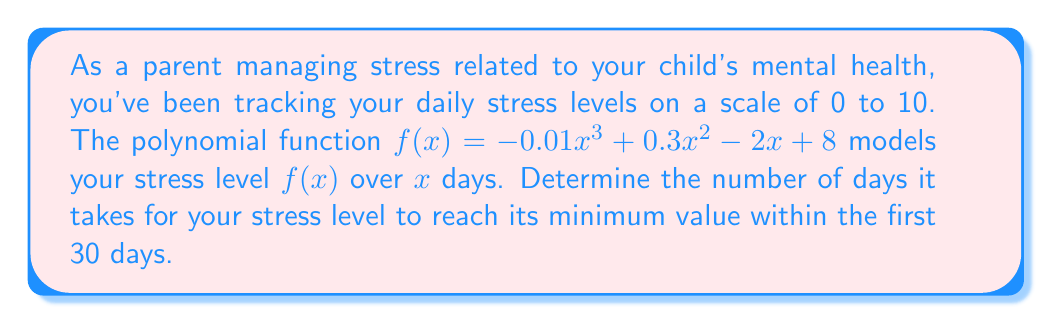Can you solve this math problem? To find the minimum stress level within the first 30 days, we need to follow these steps:

1) First, we need to find the derivative of the function to determine where the slope is zero:
   $f'(x) = -0.03x^2 + 0.6x - 2$

2) Set the derivative equal to zero and solve for x:
   $-0.03x^2 + 0.6x - 2 = 0$

3) This is a quadratic equation. We can solve it using the quadratic formula:
   $x = \frac{-b \pm \sqrt{b^2 - 4ac}}{2a}$

   Where $a = -0.03$, $b = 0.6$, and $c = -2$

4) Plugging in these values:
   $x = \frac{-0.6 \pm \sqrt{0.6^2 - 4(-0.03)(-2)}}{2(-0.03)}$
   $= \frac{-0.6 \pm \sqrt{0.36 - 0.24}}{-0.06}$
   $= \frac{-0.6 \pm \sqrt{0.12}}{-0.06}$
   $= \frac{-0.6 \pm 0.3464}{-0.06}$

5) This gives us two solutions:
   $x_1 = \frac{-0.6 + 0.3464}{-0.06} \approx 4.23$
   $x_2 = \frac{-0.6 - 0.3464}{-0.06} \approx 15.77$

6) Since we're looking within the first 30 days, both solutions are valid. However, to determine which one is the minimum (rather than a maximum), we need to check the second derivative:
   $f''(x) = -0.06x + 0.6$

7) Evaluating $f''(x)$ at both points:
   $f''(4.23) \approx 0.3462 > 0$ (indicates a minimum)
   $f''(15.77) \approx -0.3462 < 0$ (indicates a maximum)

Therefore, the stress level reaches its minimum at approximately 4.23 days.

8) Since we're asked for the number of days as an integer, we round up to 5 days.
Answer: 5 days 